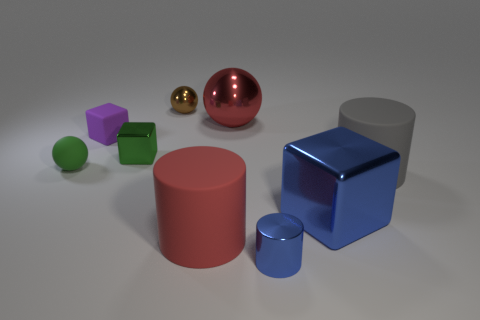Subtract 1 cubes. How many cubes are left? 2 Subtract all blocks. How many objects are left? 6 Add 1 large purple cylinders. How many objects exist? 10 Subtract 0 cyan blocks. How many objects are left? 9 Subtract all matte things. Subtract all small gray rubber cylinders. How many objects are left? 5 Add 6 small cylinders. How many small cylinders are left? 7 Add 5 small cyan metal spheres. How many small cyan metal spheres exist? 5 